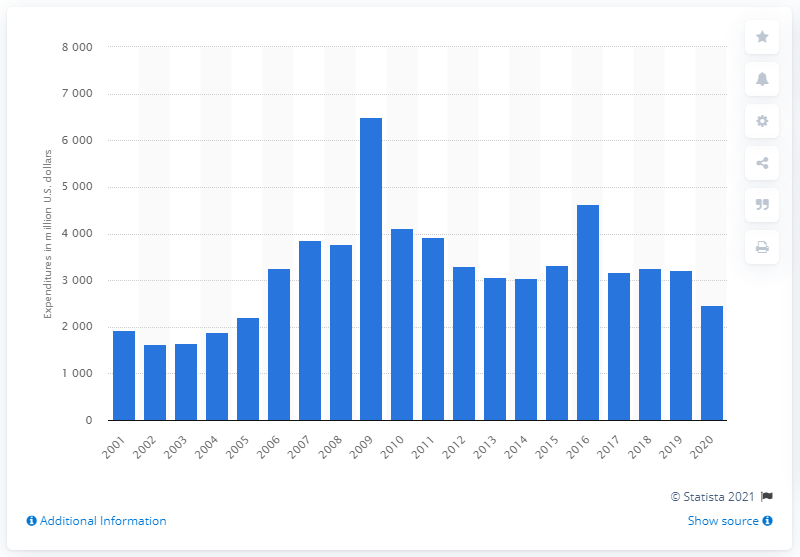What economic trend can be inferred from this chart? The chart indicates a significant surge in research and development expenditure in the late 2000s, reaching a peak in 2009, followed by a notable decrease and a period of fluctuation throughout the following decade. 